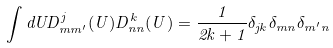Convert formula to latex. <formula><loc_0><loc_0><loc_500><loc_500>\int d U D ^ { j } _ { m m ^ { \prime } } ( U ) D ^ { k } _ { n n } ( U ) = \frac { 1 } { 2 k + 1 } \delta _ { j k } \delta _ { m n } \delta _ { m ^ { \prime } n }</formula> 